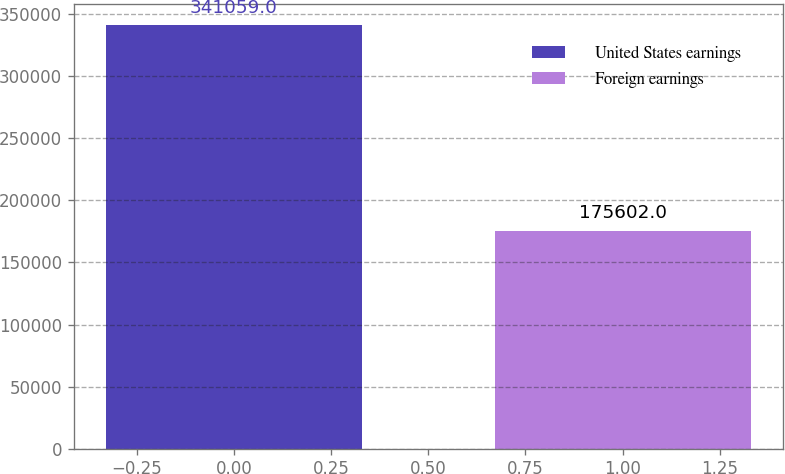<chart> <loc_0><loc_0><loc_500><loc_500><bar_chart><fcel>United States earnings<fcel>Foreign earnings<nl><fcel>341059<fcel>175602<nl></chart> 